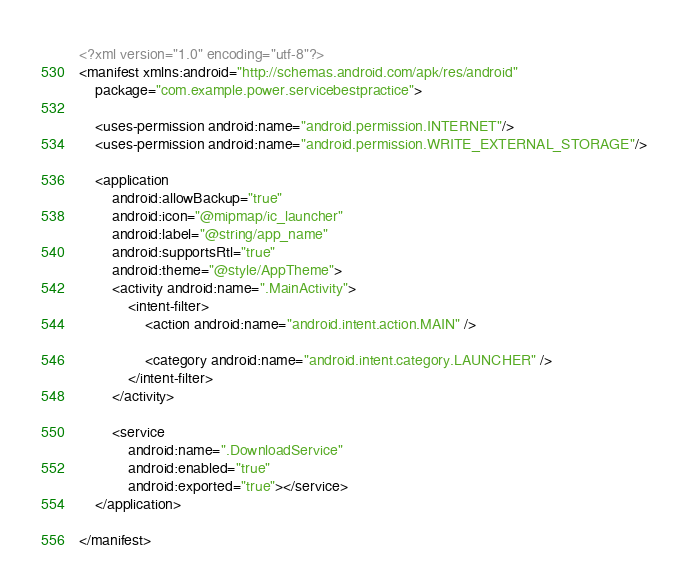Convert code to text. <code><loc_0><loc_0><loc_500><loc_500><_XML_><?xml version="1.0" encoding="utf-8"?>
<manifest xmlns:android="http://schemas.android.com/apk/res/android"
    package="com.example.power.servicebestpractice">

    <uses-permission android:name="android.permission.INTERNET"/>
    <uses-permission android:name="android.permission.WRITE_EXTERNAL_STORAGE"/>

    <application
        android:allowBackup="true"
        android:icon="@mipmap/ic_launcher"
        android:label="@string/app_name"
        android:supportsRtl="true"
        android:theme="@style/AppTheme">
        <activity android:name=".MainActivity">
            <intent-filter>
                <action android:name="android.intent.action.MAIN" />

                <category android:name="android.intent.category.LAUNCHER" />
            </intent-filter>
        </activity>

        <service
            android:name=".DownloadService"
            android:enabled="true"
            android:exported="true"></service>
    </application>

</manifest></code> 